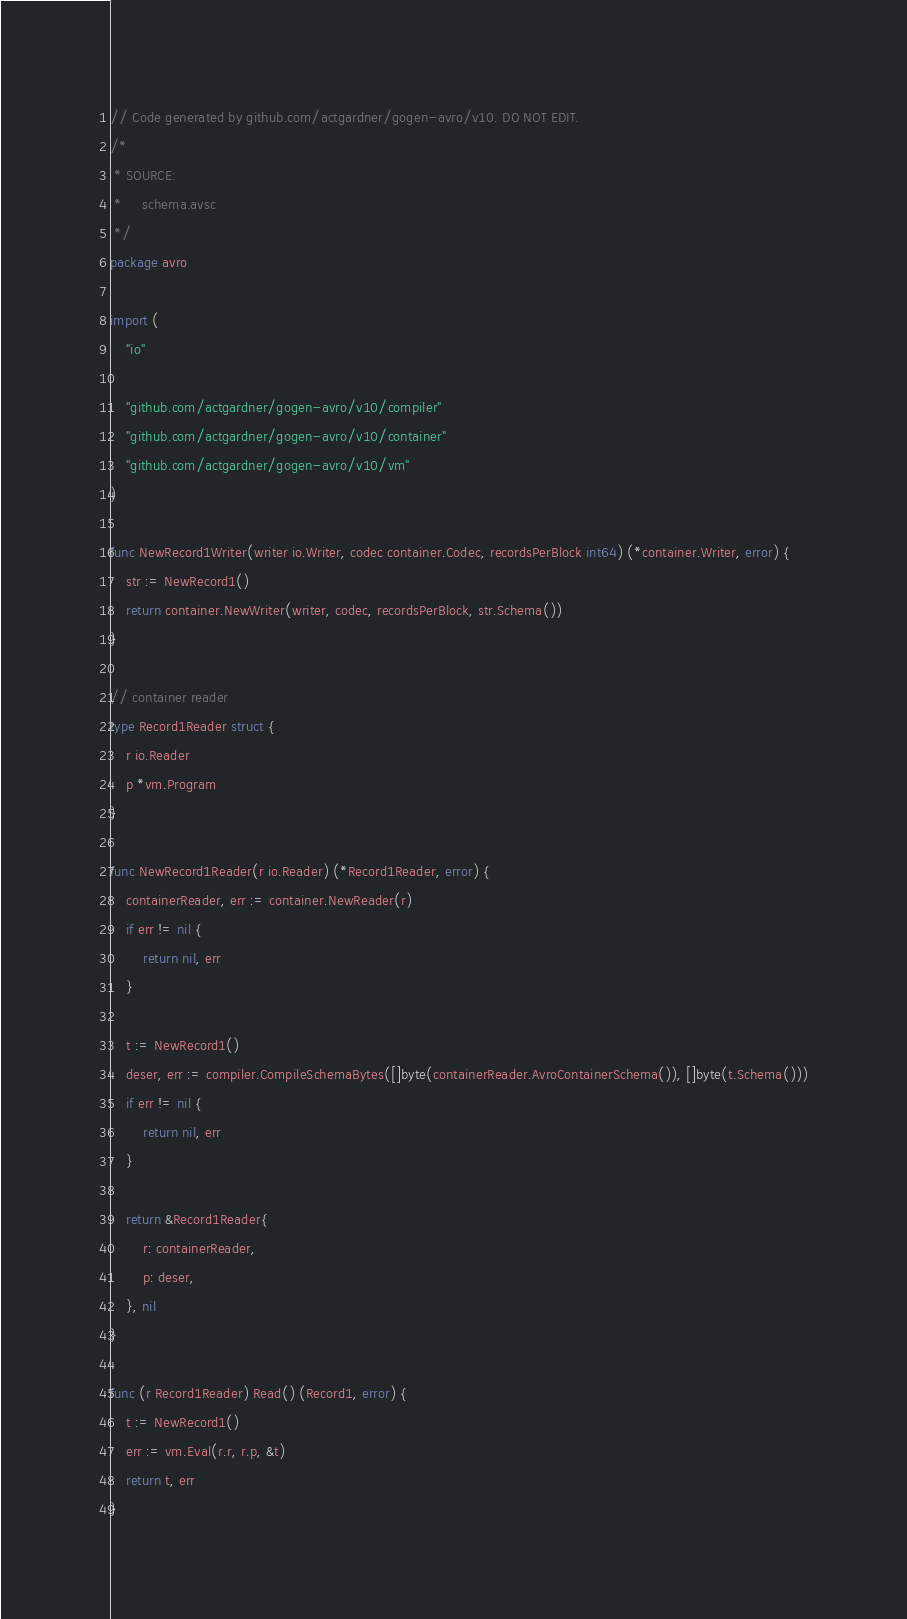<code> <loc_0><loc_0><loc_500><loc_500><_Go_>// Code generated by github.com/actgardner/gogen-avro/v10. DO NOT EDIT.
/*
 * SOURCE:
 *     schema.avsc
 */
package avro

import (
	"io"

	"github.com/actgardner/gogen-avro/v10/compiler"
	"github.com/actgardner/gogen-avro/v10/container"
	"github.com/actgardner/gogen-avro/v10/vm"
)

func NewRecord1Writer(writer io.Writer, codec container.Codec, recordsPerBlock int64) (*container.Writer, error) {
	str := NewRecord1()
	return container.NewWriter(writer, codec, recordsPerBlock, str.Schema())
}

// container reader
type Record1Reader struct {
	r io.Reader
	p *vm.Program
}

func NewRecord1Reader(r io.Reader) (*Record1Reader, error) {
	containerReader, err := container.NewReader(r)
	if err != nil {
		return nil, err
	}

	t := NewRecord1()
	deser, err := compiler.CompileSchemaBytes([]byte(containerReader.AvroContainerSchema()), []byte(t.Schema()))
	if err != nil {
		return nil, err
	}

	return &Record1Reader{
		r: containerReader,
		p: deser,
	}, nil
}

func (r Record1Reader) Read() (Record1, error) {
	t := NewRecord1()
	err := vm.Eval(r.r, r.p, &t)
	return t, err
}
</code> 